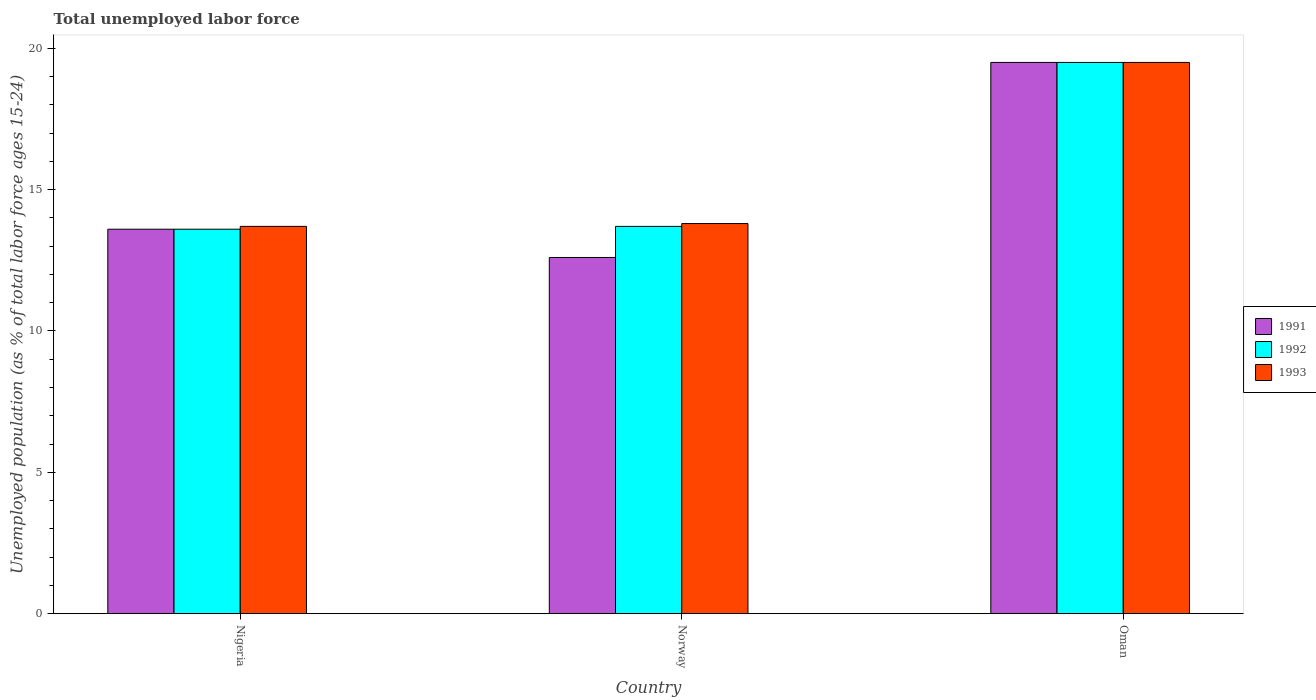How many groups of bars are there?
Keep it short and to the point. 3. Across all countries, what is the maximum percentage of unemployed population in in 1991?
Give a very brief answer. 19.5. Across all countries, what is the minimum percentage of unemployed population in in 1992?
Your answer should be very brief. 13.6. In which country was the percentage of unemployed population in in 1992 maximum?
Ensure brevity in your answer.  Oman. In which country was the percentage of unemployed population in in 1993 minimum?
Offer a terse response. Nigeria. What is the total percentage of unemployed population in in 1992 in the graph?
Keep it short and to the point. 46.8. What is the difference between the percentage of unemployed population in in 1992 in Nigeria and that in Norway?
Your answer should be very brief. -0.1. What is the average percentage of unemployed population in in 1992 per country?
Provide a succinct answer. 15.6. What is the difference between the percentage of unemployed population in of/in 1993 and percentage of unemployed population in of/in 1992 in Nigeria?
Provide a succinct answer. 0.1. What is the ratio of the percentage of unemployed population in in 1993 in Nigeria to that in Oman?
Give a very brief answer. 0.7. Is the percentage of unemployed population in in 1993 in Nigeria less than that in Norway?
Offer a very short reply. Yes. What is the difference between the highest and the second highest percentage of unemployed population in in 1991?
Ensure brevity in your answer.  6.9. What is the difference between the highest and the lowest percentage of unemployed population in in 1991?
Give a very brief answer. 6.9. In how many countries, is the percentage of unemployed population in in 1992 greater than the average percentage of unemployed population in in 1992 taken over all countries?
Your response must be concise. 1. Is the sum of the percentage of unemployed population in in 1993 in Nigeria and Oman greater than the maximum percentage of unemployed population in in 1992 across all countries?
Give a very brief answer. Yes. What does the 2nd bar from the right in Norway represents?
Keep it short and to the point. 1992. Is it the case that in every country, the sum of the percentage of unemployed population in in 1993 and percentage of unemployed population in in 1992 is greater than the percentage of unemployed population in in 1991?
Your answer should be compact. Yes. How many bars are there?
Your response must be concise. 9. How many countries are there in the graph?
Make the answer very short. 3. Are the values on the major ticks of Y-axis written in scientific E-notation?
Your answer should be compact. No. Does the graph contain any zero values?
Provide a succinct answer. No. Does the graph contain grids?
Your response must be concise. No. What is the title of the graph?
Your response must be concise. Total unemployed labor force. Does "2002" appear as one of the legend labels in the graph?
Your answer should be very brief. No. What is the label or title of the X-axis?
Provide a succinct answer. Country. What is the label or title of the Y-axis?
Provide a succinct answer. Unemployed population (as % of total labor force ages 15-24). What is the Unemployed population (as % of total labor force ages 15-24) of 1991 in Nigeria?
Your answer should be compact. 13.6. What is the Unemployed population (as % of total labor force ages 15-24) of 1992 in Nigeria?
Provide a succinct answer. 13.6. What is the Unemployed population (as % of total labor force ages 15-24) of 1993 in Nigeria?
Provide a succinct answer. 13.7. What is the Unemployed population (as % of total labor force ages 15-24) in 1991 in Norway?
Your answer should be compact. 12.6. What is the Unemployed population (as % of total labor force ages 15-24) in 1992 in Norway?
Your response must be concise. 13.7. What is the Unemployed population (as % of total labor force ages 15-24) of 1993 in Norway?
Provide a succinct answer. 13.8. What is the Unemployed population (as % of total labor force ages 15-24) of 1992 in Oman?
Offer a terse response. 19.5. What is the Unemployed population (as % of total labor force ages 15-24) of 1993 in Oman?
Your answer should be very brief. 19.5. Across all countries, what is the maximum Unemployed population (as % of total labor force ages 15-24) in 1991?
Offer a terse response. 19.5. Across all countries, what is the minimum Unemployed population (as % of total labor force ages 15-24) in 1991?
Your answer should be very brief. 12.6. Across all countries, what is the minimum Unemployed population (as % of total labor force ages 15-24) of 1992?
Your answer should be compact. 13.6. Across all countries, what is the minimum Unemployed population (as % of total labor force ages 15-24) of 1993?
Your response must be concise. 13.7. What is the total Unemployed population (as % of total labor force ages 15-24) in 1991 in the graph?
Offer a terse response. 45.7. What is the total Unemployed population (as % of total labor force ages 15-24) in 1992 in the graph?
Keep it short and to the point. 46.8. What is the total Unemployed population (as % of total labor force ages 15-24) of 1993 in the graph?
Give a very brief answer. 47. What is the difference between the Unemployed population (as % of total labor force ages 15-24) of 1991 in Nigeria and that in Norway?
Ensure brevity in your answer.  1. What is the difference between the Unemployed population (as % of total labor force ages 15-24) of 1992 in Nigeria and that in Norway?
Make the answer very short. -0.1. What is the difference between the Unemployed population (as % of total labor force ages 15-24) of 1991 in Nigeria and that in Oman?
Make the answer very short. -5.9. What is the difference between the Unemployed population (as % of total labor force ages 15-24) of 1993 in Nigeria and that in Oman?
Provide a short and direct response. -5.8. What is the difference between the Unemployed population (as % of total labor force ages 15-24) in 1991 in Norway and that in Oman?
Give a very brief answer. -6.9. What is the difference between the Unemployed population (as % of total labor force ages 15-24) in 1993 in Norway and that in Oman?
Your answer should be compact. -5.7. What is the difference between the Unemployed population (as % of total labor force ages 15-24) of 1991 in Nigeria and the Unemployed population (as % of total labor force ages 15-24) of 1992 in Norway?
Offer a terse response. -0.1. What is the difference between the Unemployed population (as % of total labor force ages 15-24) in 1991 in Nigeria and the Unemployed population (as % of total labor force ages 15-24) in 1993 in Norway?
Your response must be concise. -0.2. What is the difference between the Unemployed population (as % of total labor force ages 15-24) of 1991 in Nigeria and the Unemployed population (as % of total labor force ages 15-24) of 1992 in Oman?
Ensure brevity in your answer.  -5.9. What is the difference between the Unemployed population (as % of total labor force ages 15-24) in 1992 in Nigeria and the Unemployed population (as % of total labor force ages 15-24) in 1993 in Oman?
Offer a very short reply. -5.9. What is the difference between the Unemployed population (as % of total labor force ages 15-24) of 1991 in Norway and the Unemployed population (as % of total labor force ages 15-24) of 1992 in Oman?
Provide a succinct answer. -6.9. What is the difference between the Unemployed population (as % of total labor force ages 15-24) of 1992 in Norway and the Unemployed population (as % of total labor force ages 15-24) of 1993 in Oman?
Provide a short and direct response. -5.8. What is the average Unemployed population (as % of total labor force ages 15-24) in 1991 per country?
Ensure brevity in your answer.  15.23. What is the average Unemployed population (as % of total labor force ages 15-24) of 1993 per country?
Give a very brief answer. 15.67. What is the difference between the Unemployed population (as % of total labor force ages 15-24) of 1991 and Unemployed population (as % of total labor force ages 15-24) of 1992 in Nigeria?
Provide a succinct answer. 0. What is the difference between the Unemployed population (as % of total labor force ages 15-24) in 1991 and Unemployed population (as % of total labor force ages 15-24) in 1993 in Nigeria?
Offer a terse response. -0.1. What is the difference between the Unemployed population (as % of total labor force ages 15-24) in 1991 and Unemployed population (as % of total labor force ages 15-24) in 1992 in Oman?
Your answer should be compact. 0. What is the ratio of the Unemployed population (as % of total labor force ages 15-24) of 1991 in Nigeria to that in Norway?
Provide a succinct answer. 1.08. What is the ratio of the Unemployed population (as % of total labor force ages 15-24) of 1993 in Nigeria to that in Norway?
Your answer should be compact. 0.99. What is the ratio of the Unemployed population (as % of total labor force ages 15-24) in 1991 in Nigeria to that in Oman?
Give a very brief answer. 0.7. What is the ratio of the Unemployed population (as % of total labor force ages 15-24) of 1992 in Nigeria to that in Oman?
Provide a short and direct response. 0.7. What is the ratio of the Unemployed population (as % of total labor force ages 15-24) of 1993 in Nigeria to that in Oman?
Your answer should be very brief. 0.7. What is the ratio of the Unemployed population (as % of total labor force ages 15-24) of 1991 in Norway to that in Oman?
Keep it short and to the point. 0.65. What is the ratio of the Unemployed population (as % of total labor force ages 15-24) of 1992 in Norway to that in Oman?
Give a very brief answer. 0.7. What is the ratio of the Unemployed population (as % of total labor force ages 15-24) in 1993 in Norway to that in Oman?
Your response must be concise. 0.71. What is the difference between the highest and the second highest Unemployed population (as % of total labor force ages 15-24) of 1992?
Keep it short and to the point. 5.8. 